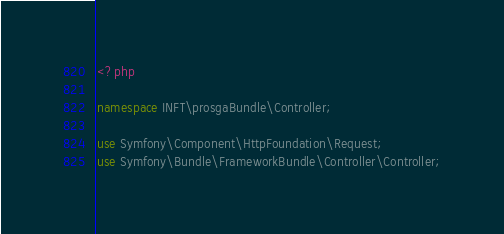<code> <loc_0><loc_0><loc_500><loc_500><_PHP_><?php

namespace INFT\prosgaBundle\Controller;

use Symfony\Component\HttpFoundation\Request;
use Symfony\Bundle\FrameworkBundle\Controller\Controller;</code> 